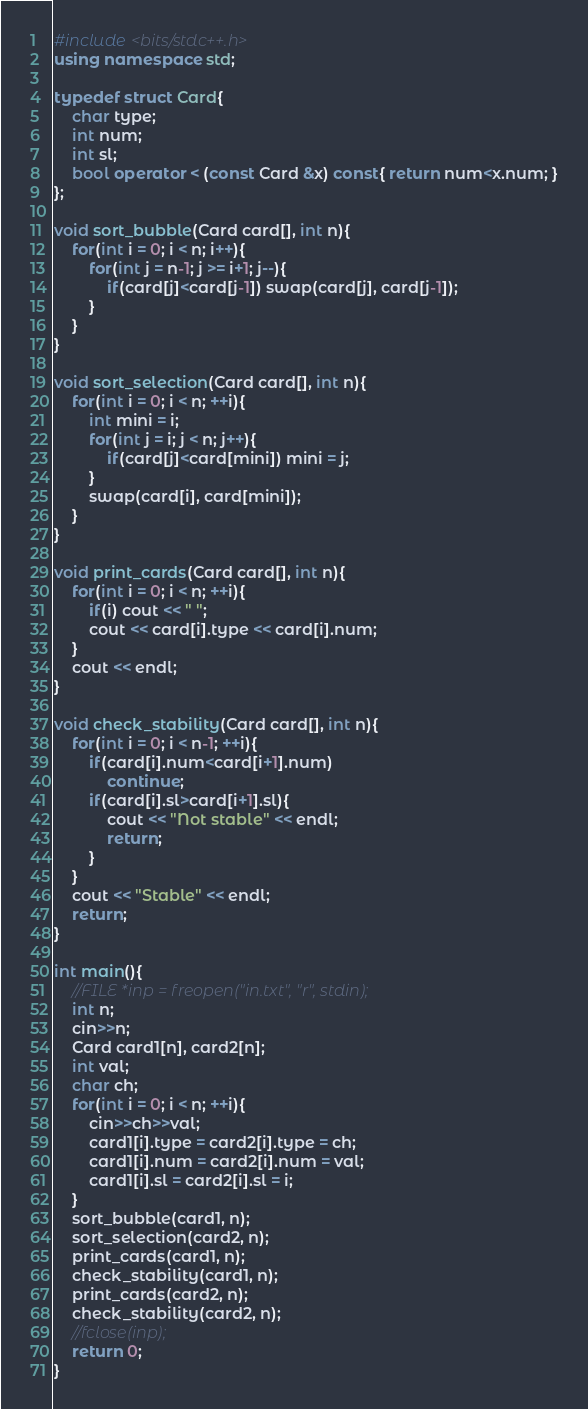<code> <loc_0><loc_0><loc_500><loc_500><_C++_>#include <bits/stdc++.h>
using namespace std;

typedef struct Card{
    char type;
    int num;
    int sl;
    bool operator < (const Card &x) const{ return num<x.num; }
};

void sort_bubble(Card card[], int n){
    for(int i = 0; i < n; i++){
        for(int j = n-1; j >= i+1; j--){
            if(card[j]<card[j-1]) swap(card[j], card[j-1]);
        }
    }
}

void sort_selection(Card card[], int n){
    for(int i = 0; i < n; ++i){
        int mini = i;
        for(int j = i; j < n; j++){
            if(card[j]<card[mini]) mini = j;
        }
        swap(card[i], card[mini]);
    }
}

void print_cards(Card card[], int n){
    for(int i = 0; i < n; ++i){
        if(i) cout << " ";
        cout << card[i].type << card[i].num;
    }
    cout << endl;
}

void check_stability(Card card[], int n){
    for(int i = 0; i < n-1; ++i){
        if(card[i].num<card[i+1].num)
            continue;
        if(card[i].sl>card[i+1].sl){
            cout << "Not stable" << endl;
            return;
        }
    }
    cout << "Stable" << endl;
    return;
}

int main(){
    //FILE *inp = freopen("in.txt", "r", stdin);
    int n;
    cin>>n;
    Card card1[n], card2[n];
    int val;
    char ch;
    for(int i = 0; i < n; ++i){
        cin>>ch>>val;
        card1[i].type = card2[i].type = ch;
        card1[i].num = card2[i].num = val;
        card1[i].sl = card2[i].sl = i;
    }
    sort_bubble(card1, n);
    sort_selection(card2, n);
    print_cards(card1, n);
    check_stability(card1, n);
    print_cards(card2, n);
    check_stability(card2, n);
    //fclose(inp);
    return 0;
}</code> 